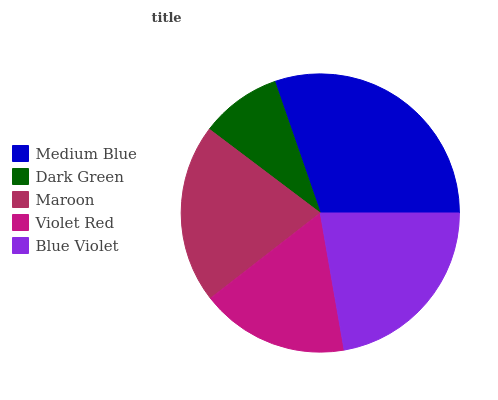Is Dark Green the minimum?
Answer yes or no. Yes. Is Medium Blue the maximum?
Answer yes or no. Yes. Is Maroon the minimum?
Answer yes or no. No. Is Maroon the maximum?
Answer yes or no. No. Is Maroon greater than Dark Green?
Answer yes or no. Yes. Is Dark Green less than Maroon?
Answer yes or no. Yes. Is Dark Green greater than Maroon?
Answer yes or no. No. Is Maroon less than Dark Green?
Answer yes or no. No. Is Maroon the high median?
Answer yes or no. Yes. Is Maroon the low median?
Answer yes or no. Yes. Is Blue Violet the high median?
Answer yes or no. No. Is Medium Blue the low median?
Answer yes or no. No. 